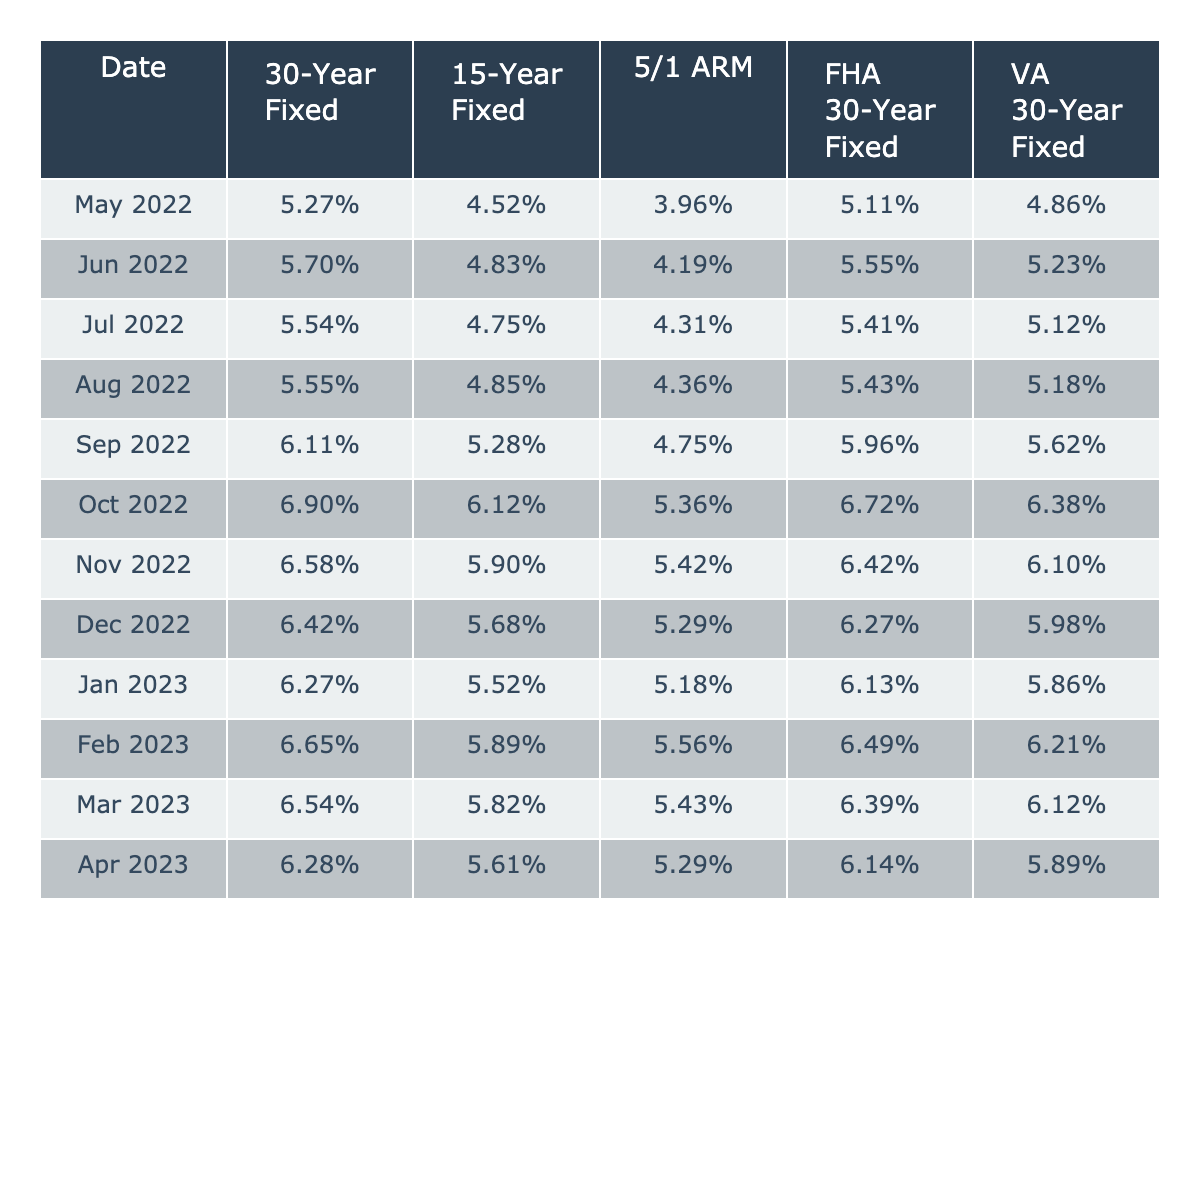What was the highest interest rate for a 30-Year Fixed mortgage in the past year? The highest interest rate for a 30-Year Fixed mortgage is found in October 2022, where it reached 6.90%.
Answer: 6.90% What interest rate trends can be observed for the 15-Year Fixed mortgage over the year? The interest rates for the 15-Year Fixed mortgage initially increased from May to October 2022, then decreased slightly to 5.52% in January 2023, before experiencing small fluctuations to 5.61% in April 2023.
Answer: Fluctuating downwards after October What is the average interest rate for the FHA 30-Year Fixed mortgage over the past year? To find the average, sum the FHA 30-Year Fixed rates across all months, which results in (5.11 + 5.55 + 5.41 + 5.43 + 5.96 + 6.72 + 6.42 + 6.27 + 6.13 + 6.49 + 6.39 + 6.14) = 70.017%, and then divide by 12 months: 70.017% / 12 = 5.84%.
Answer: 5.84% Did the interest rate for the 5/1 ARM mortgage ever reach over 5.5% in 2022? The highest interest rate for the 5/1 ARM mortgage in 2022 was 5.43%, occurring in November and December, which is below 5.5%.
Answer: No Which loan type had the lowest interest rate in June 2022? To answer this, examine the rates for each loan type in June 2022: 30-Year Fixed (5.70%), 15-Year Fixed (4.83%), 5/1 ARM (4.19%), FHA 30-Year Fixed (5.55%), VA 30-Year Fixed (5.23%). The lowest is 4.19% for the 5/1 ARM.
Answer: 5/1 ARM What was the difference in interest rates between the 30-Year Fixed and VA 30-Year Fixed loans in March 2023? In March 2023, the 30-Year Fixed rate was 6.54% and the VA 30-Year Fixed was 6.12%. The difference is calculated as 6.54% - 6.12% = 0.42%.
Answer: 0.42% Which mortgage type consistently had the highest interest rates in the past year? Reviewing the data, the 30-Year Fixed mortgage rates were generally higher than other types in most months, especially peaking at 6.90% in October 2022.
Answer: 30-Year Fixed What was the percentage decrease in interest rate from October 2022 to January 2023 for the 15-Year Fixed? The 15-Year Fixed rate in October 2022 was 6.12% and in January 2023 was 5.52%. The decrease is calculated as (6.12% - 5.52%) = 0.60%, showing a decrease of approximately 9.8%.
Answer: 0.60% In which month did the FHA 30-Year Fixed mortgage have its lowest interest rate? The FHA 30-Year Fixed mortgage rate was lowest in January 2023 at 6.13%, making it the month with the lowest rate for this loan type over the recorded year.
Answer: January 2023 How many months did the interest rate for the 5/1 ARM loan remain below 4%? The 5/1 ARM interest rate never fell below 4%. The lowest recorded rate was 3.96% in May 2022, but it increased in subsequent months and never returned below 4%.
Answer: 0 months 